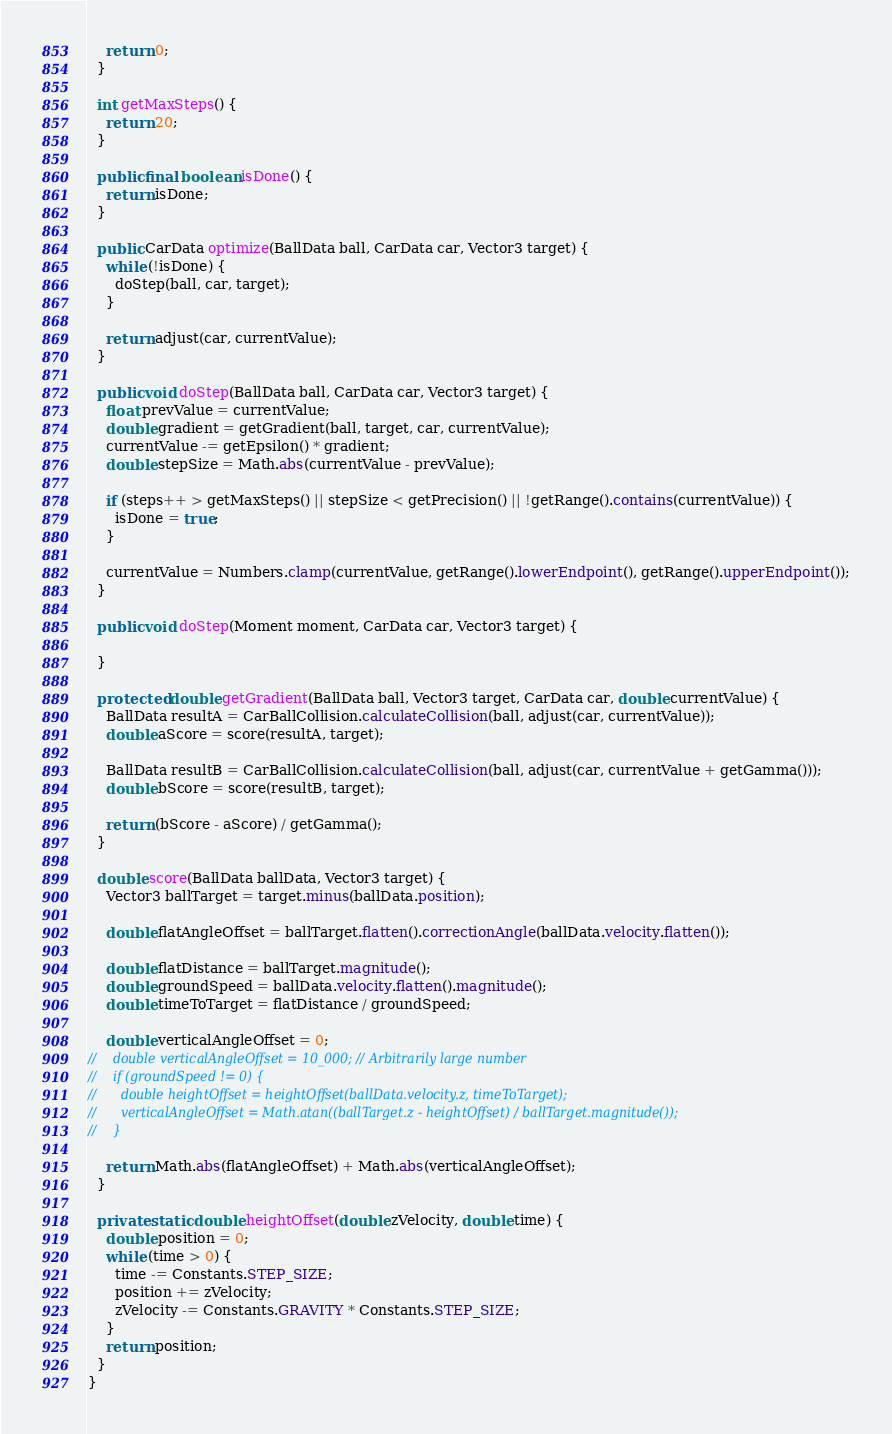<code> <loc_0><loc_0><loc_500><loc_500><_Java_>    return 0;
  }

  int getMaxSteps() {
    return 20;
  }

  public final boolean isDone() {
    return isDone;
  }

  public CarData optimize(BallData ball, CarData car, Vector3 target) {
    while (!isDone) {
      doStep(ball, car, target);
    }

    return adjust(car, currentValue);
  }

  public void doStep(BallData ball, CarData car, Vector3 target) {
    float prevValue = currentValue;
    double gradient = getGradient(ball, target, car, currentValue);
    currentValue -= getEpsilon() * gradient;
    double stepSize = Math.abs(currentValue - prevValue);

    if (steps++ > getMaxSteps() || stepSize < getPrecision() || !getRange().contains(currentValue)) {
      isDone = true;
    }

    currentValue = Numbers.clamp(currentValue, getRange().lowerEndpoint(), getRange().upperEndpoint());
  }

  public void doStep(Moment moment, CarData car, Vector3 target) {

  }

  protected double getGradient(BallData ball, Vector3 target, CarData car, double currentValue) {
    BallData resultA = CarBallCollision.calculateCollision(ball, adjust(car, currentValue));
    double aScore = score(resultA, target);

    BallData resultB = CarBallCollision.calculateCollision(ball, adjust(car, currentValue + getGamma()));
    double bScore = score(resultB, target);

    return (bScore - aScore) / getGamma();
  }

  double score(BallData ballData, Vector3 target) {
    Vector3 ballTarget = target.minus(ballData.position);

    double flatAngleOffset = ballTarget.flatten().correctionAngle(ballData.velocity.flatten());

    double flatDistance = ballTarget.magnitude();
    double groundSpeed = ballData.velocity.flatten().magnitude();
    double timeToTarget = flatDistance / groundSpeed;

    double verticalAngleOffset = 0;
//    double verticalAngleOffset = 10_000; // Arbitrarily large number
//    if (groundSpeed != 0) {
//      double heightOffset = heightOffset(ballData.velocity.z, timeToTarget);
//      verticalAngleOffset = Math.atan((ballTarget.z - heightOffset) / ballTarget.magnitude());
//    }

    return Math.abs(flatAngleOffset) + Math.abs(verticalAngleOffset);
  }

  private static double heightOffset(double zVelocity, double time) {
    double position = 0;
    while (time > 0) {
      time -= Constants.STEP_SIZE;
      position += zVelocity;
      zVelocity -= Constants.GRAVITY * Constants.STEP_SIZE;
    }
    return position;
  }
}
</code> 